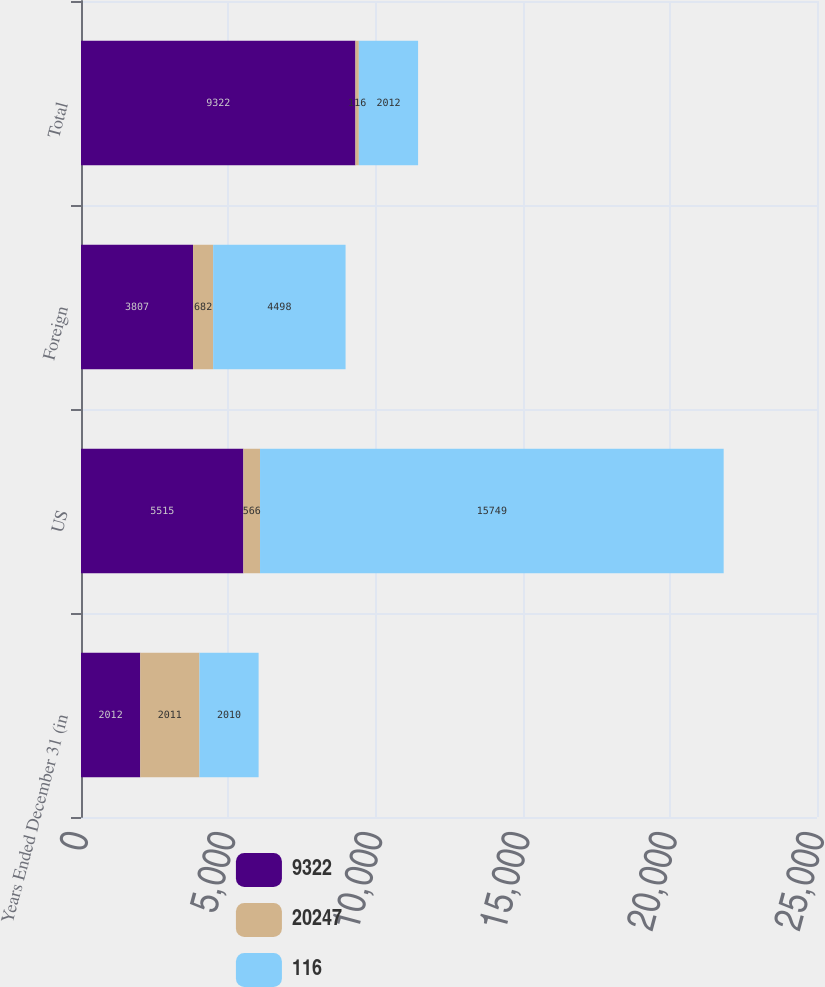Convert chart. <chart><loc_0><loc_0><loc_500><loc_500><stacked_bar_chart><ecel><fcel>Years Ended December 31 (in<fcel>US<fcel>Foreign<fcel>Total<nl><fcel>9322<fcel>2012<fcel>5515<fcel>3807<fcel>9322<nl><fcel>20247<fcel>2011<fcel>566<fcel>682<fcel>116<nl><fcel>116<fcel>2010<fcel>15749<fcel>4498<fcel>2012<nl></chart> 